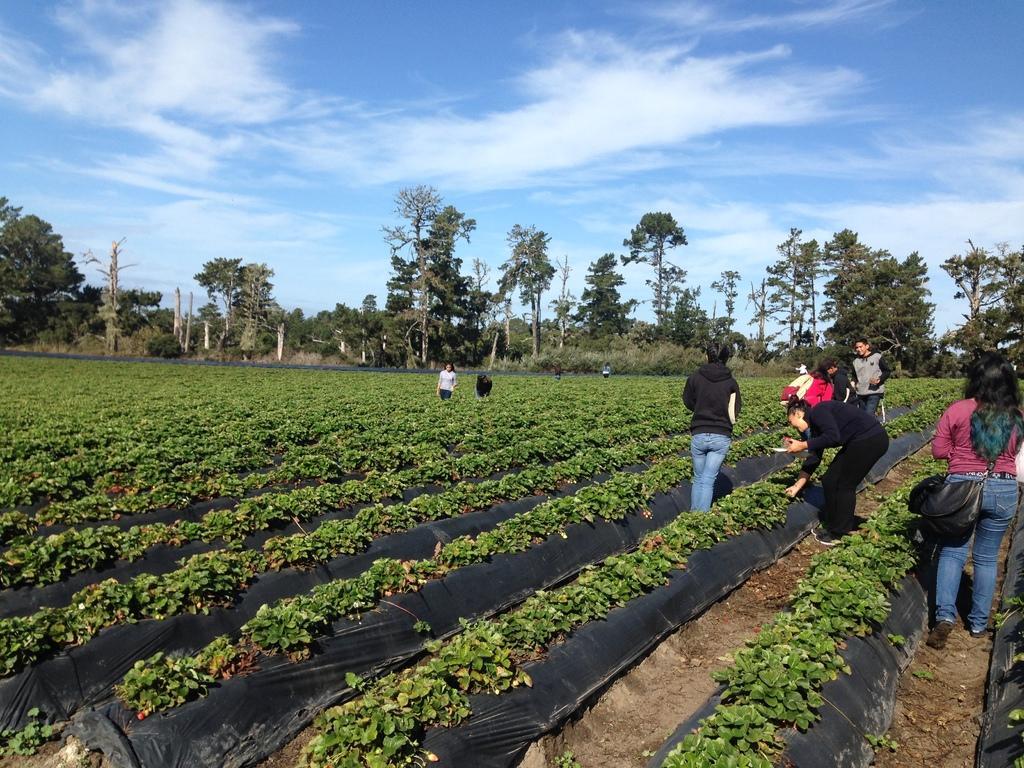In one or two sentences, can you explain what this image depicts? In this image I can see few plants and trees. There are few persons standing. At the top I can see clouds in the sky. 